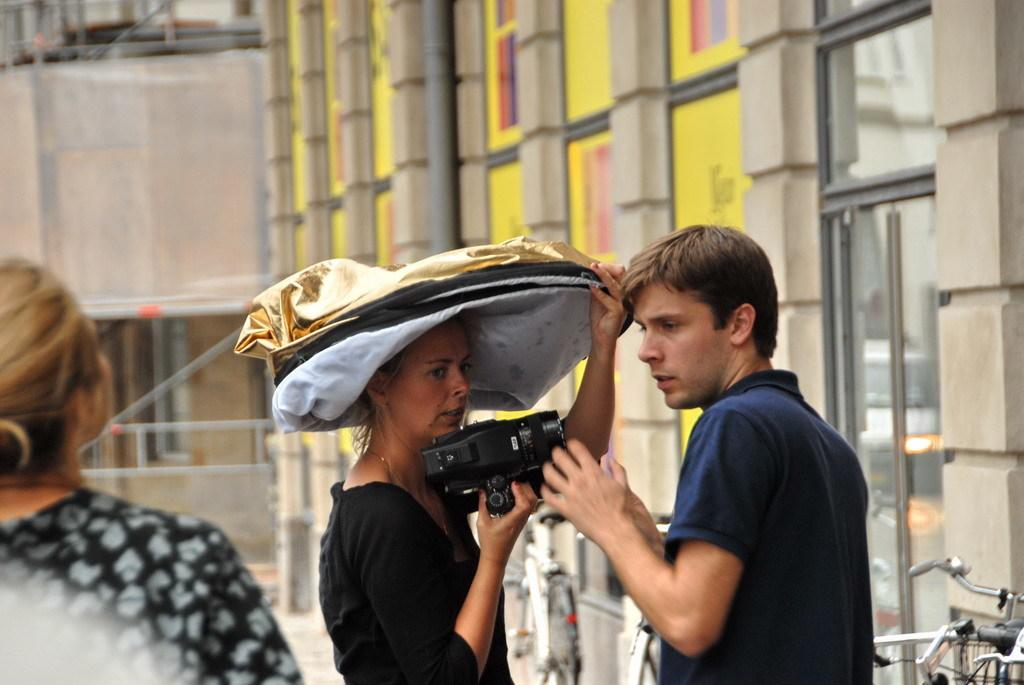How many people are present in the image? There are three people in the image: one man and two women. What is the woman holding in her hand? One of the women is holding an object in her hand, but the specific object is not mentioned in the facts. What can be seen in the background of the image? There are buildings in the background of the image. What type of comfort can be seen in the image? There is no mention of comfort in the image, as it focuses on the people and the buildings in the background. Is there any rice visible in the image? There is no mention of rice in the image. 